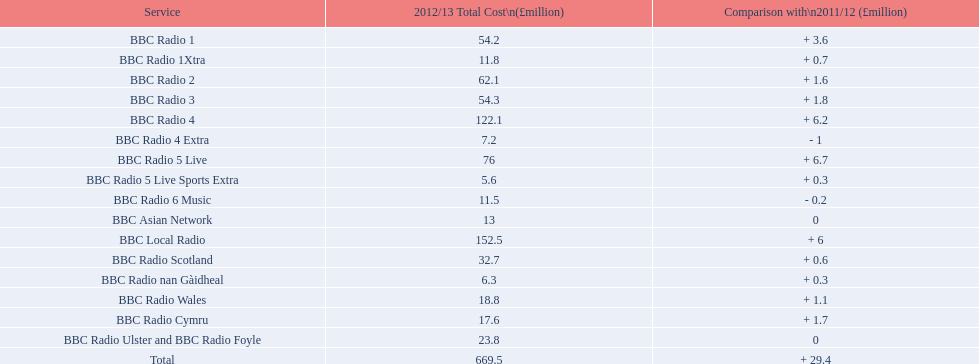What is the maximum expenditure for running a station in 2012/13? 152.5. What station had an operational cost of 152.5 million pounds at this time? BBC Local Radio. 